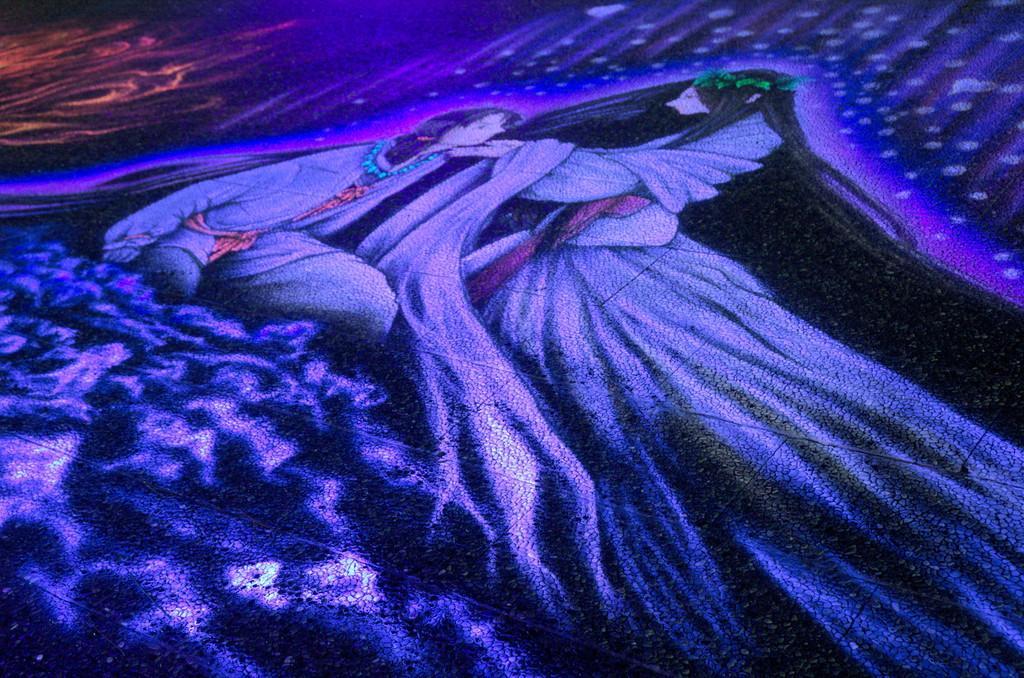Can you describe this image briefly? In this image there is a painting of two people. 